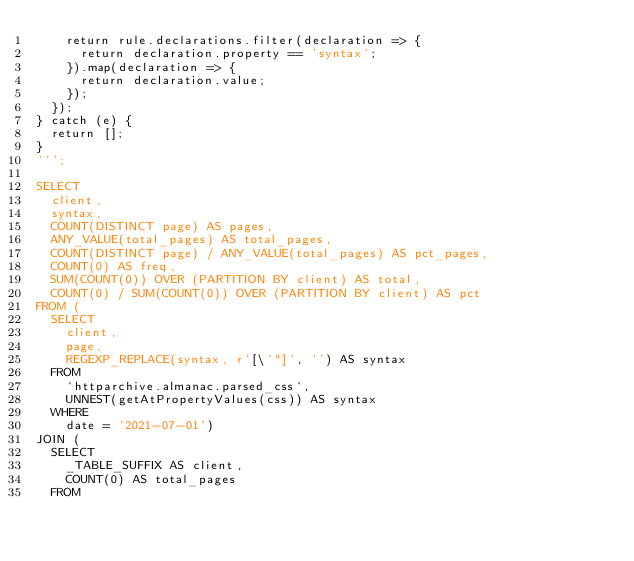Convert code to text. <code><loc_0><loc_0><loc_500><loc_500><_SQL_>    return rule.declarations.filter(declaration => {
      return declaration.property == 'syntax';
    }).map(declaration => {
      return declaration.value;
    });
  });
} catch (e) {
  return [];
}
''';

SELECT
  client,
  syntax,
  COUNT(DISTINCT page) AS pages,
  ANY_VALUE(total_pages) AS total_pages,
  COUNT(DISTINCT page) / ANY_VALUE(total_pages) AS pct_pages,
  COUNT(0) AS freq,
  SUM(COUNT(0)) OVER (PARTITION BY client) AS total,
  COUNT(0) / SUM(COUNT(0)) OVER (PARTITION BY client) AS pct
FROM (
  SELECT
    client,
    page,
    REGEXP_REPLACE(syntax, r'[\'"]', '') AS syntax
  FROM
    `httparchive.almanac.parsed_css`,
    UNNEST(getAtPropertyValues(css)) AS syntax
  WHERE
    date = '2021-07-01')
JOIN (
  SELECT
    _TABLE_SUFFIX AS client,
    COUNT(0) AS total_pages
  FROM</code> 